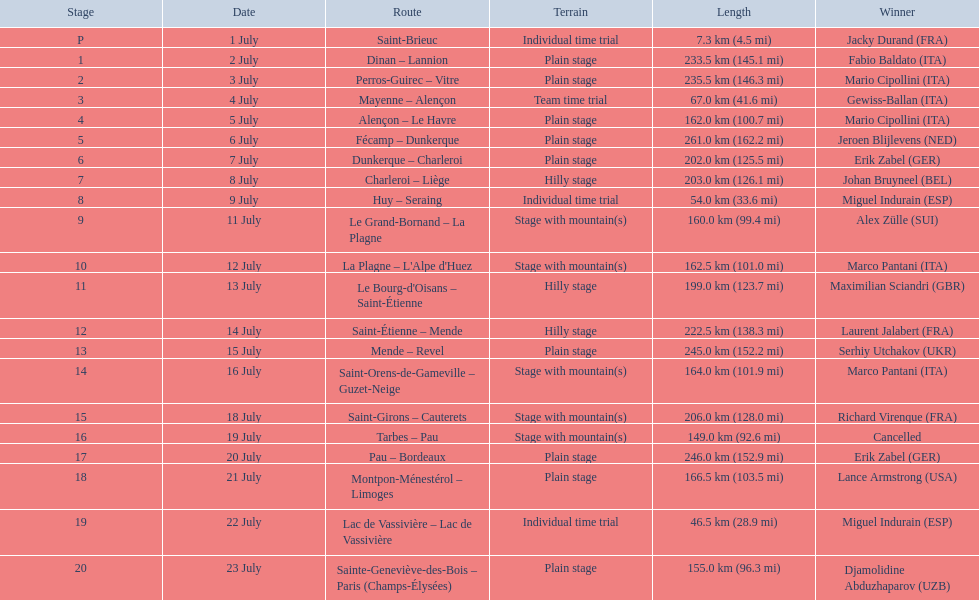What are the periods? 1 July, 2 July, 3 July, 4 July, 5 July, 6 July, 7 July, 8 July, 9 July, 11 July, 12 July, 13 July, 14 July, 15 July, 16 July, 18 July, 19 July, 20 July, 21 July, 22 July, 23 July. What is the extent on july 8? 203.0 km (126.1 mi). 